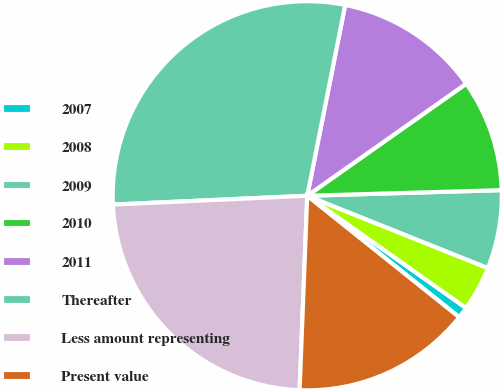<chart> <loc_0><loc_0><loc_500><loc_500><pie_chart><fcel>2007<fcel>2008<fcel>2009<fcel>2010<fcel>2011<fcel>Thereafter<fcel>Less amount representing<fcel>Present value<nl><fcel>0.94%<fcel>3.73%<fcel>6.52%<fcel>9.31%<fcel>12.1%<fcel>28.84%<fcel>23.65%<fcel>14.89%<nl></chart> 